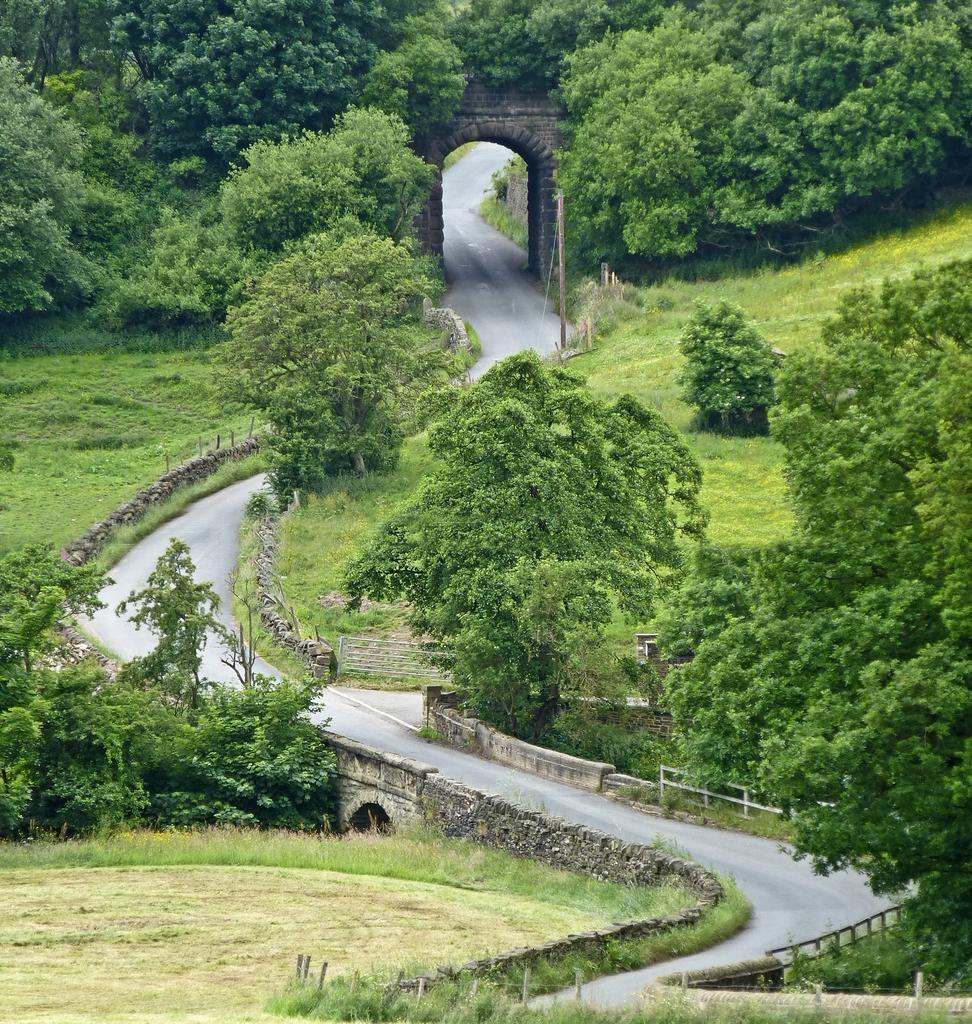Can you describe this image briefly? Beside this road we can see grass, plants and trees. 